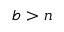Convert formula to latex. <formula><loc_0><loc_0><loc_500><loc_500>b > n</formula> 